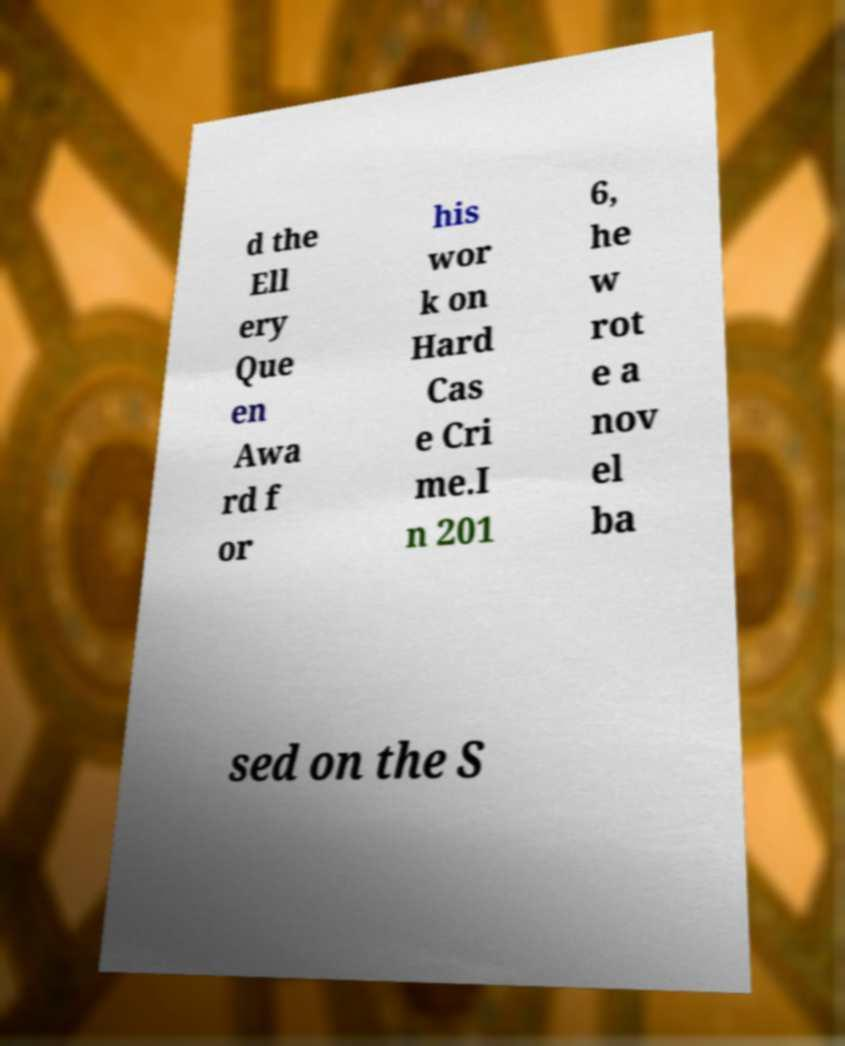I need the written content from this picture converted into text. Can you do that? d the Ell ery Que en Awa rd f or his wor k on Hard Cas e Cri me.I n 201 6, he w rot e a nov el ba sed on the S 